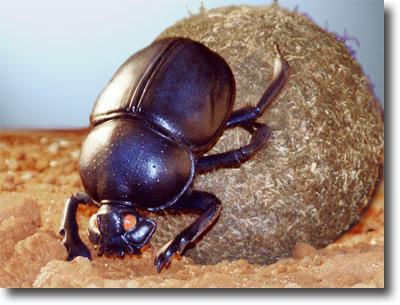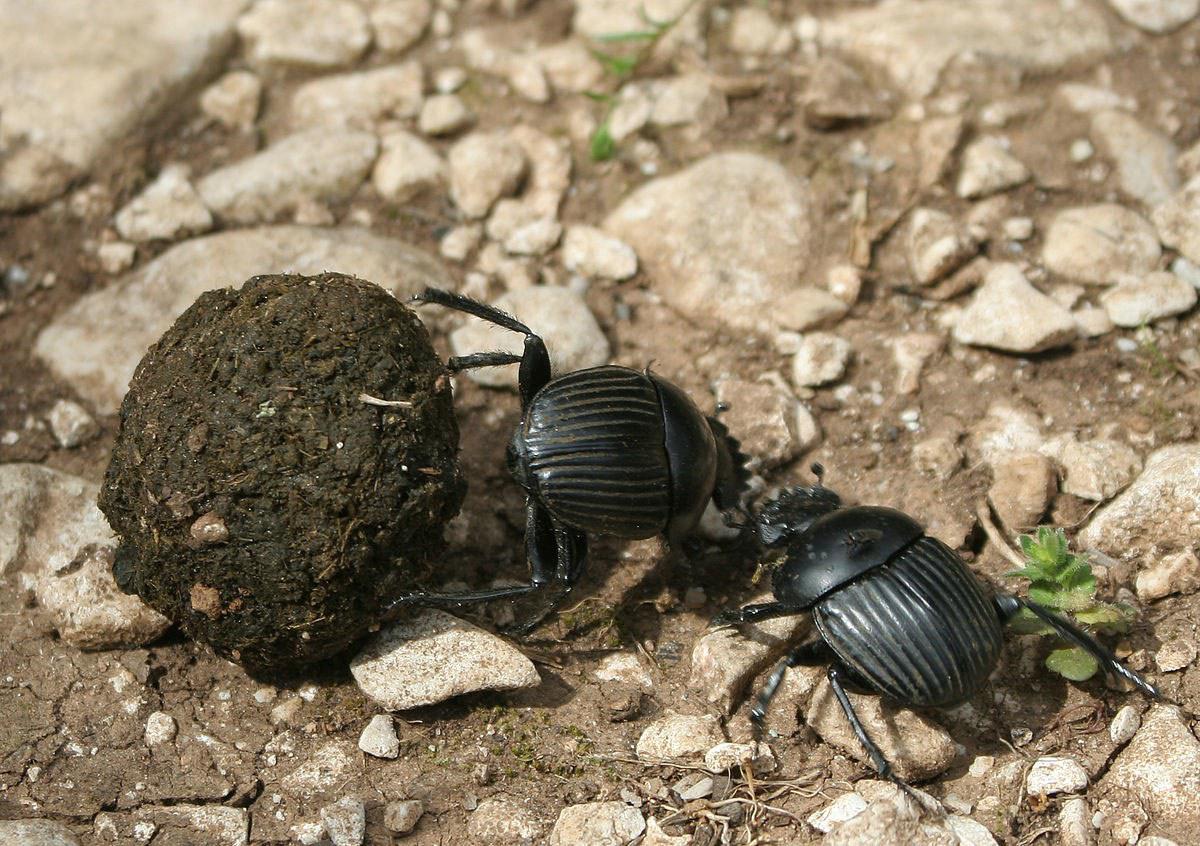The first image is the image on the left, the second image is the image on the right. Analyze the images presented: Is the assertion "There is at least one black spot on the back of the insect in one of the images." valid? Answer yes or no. No. 